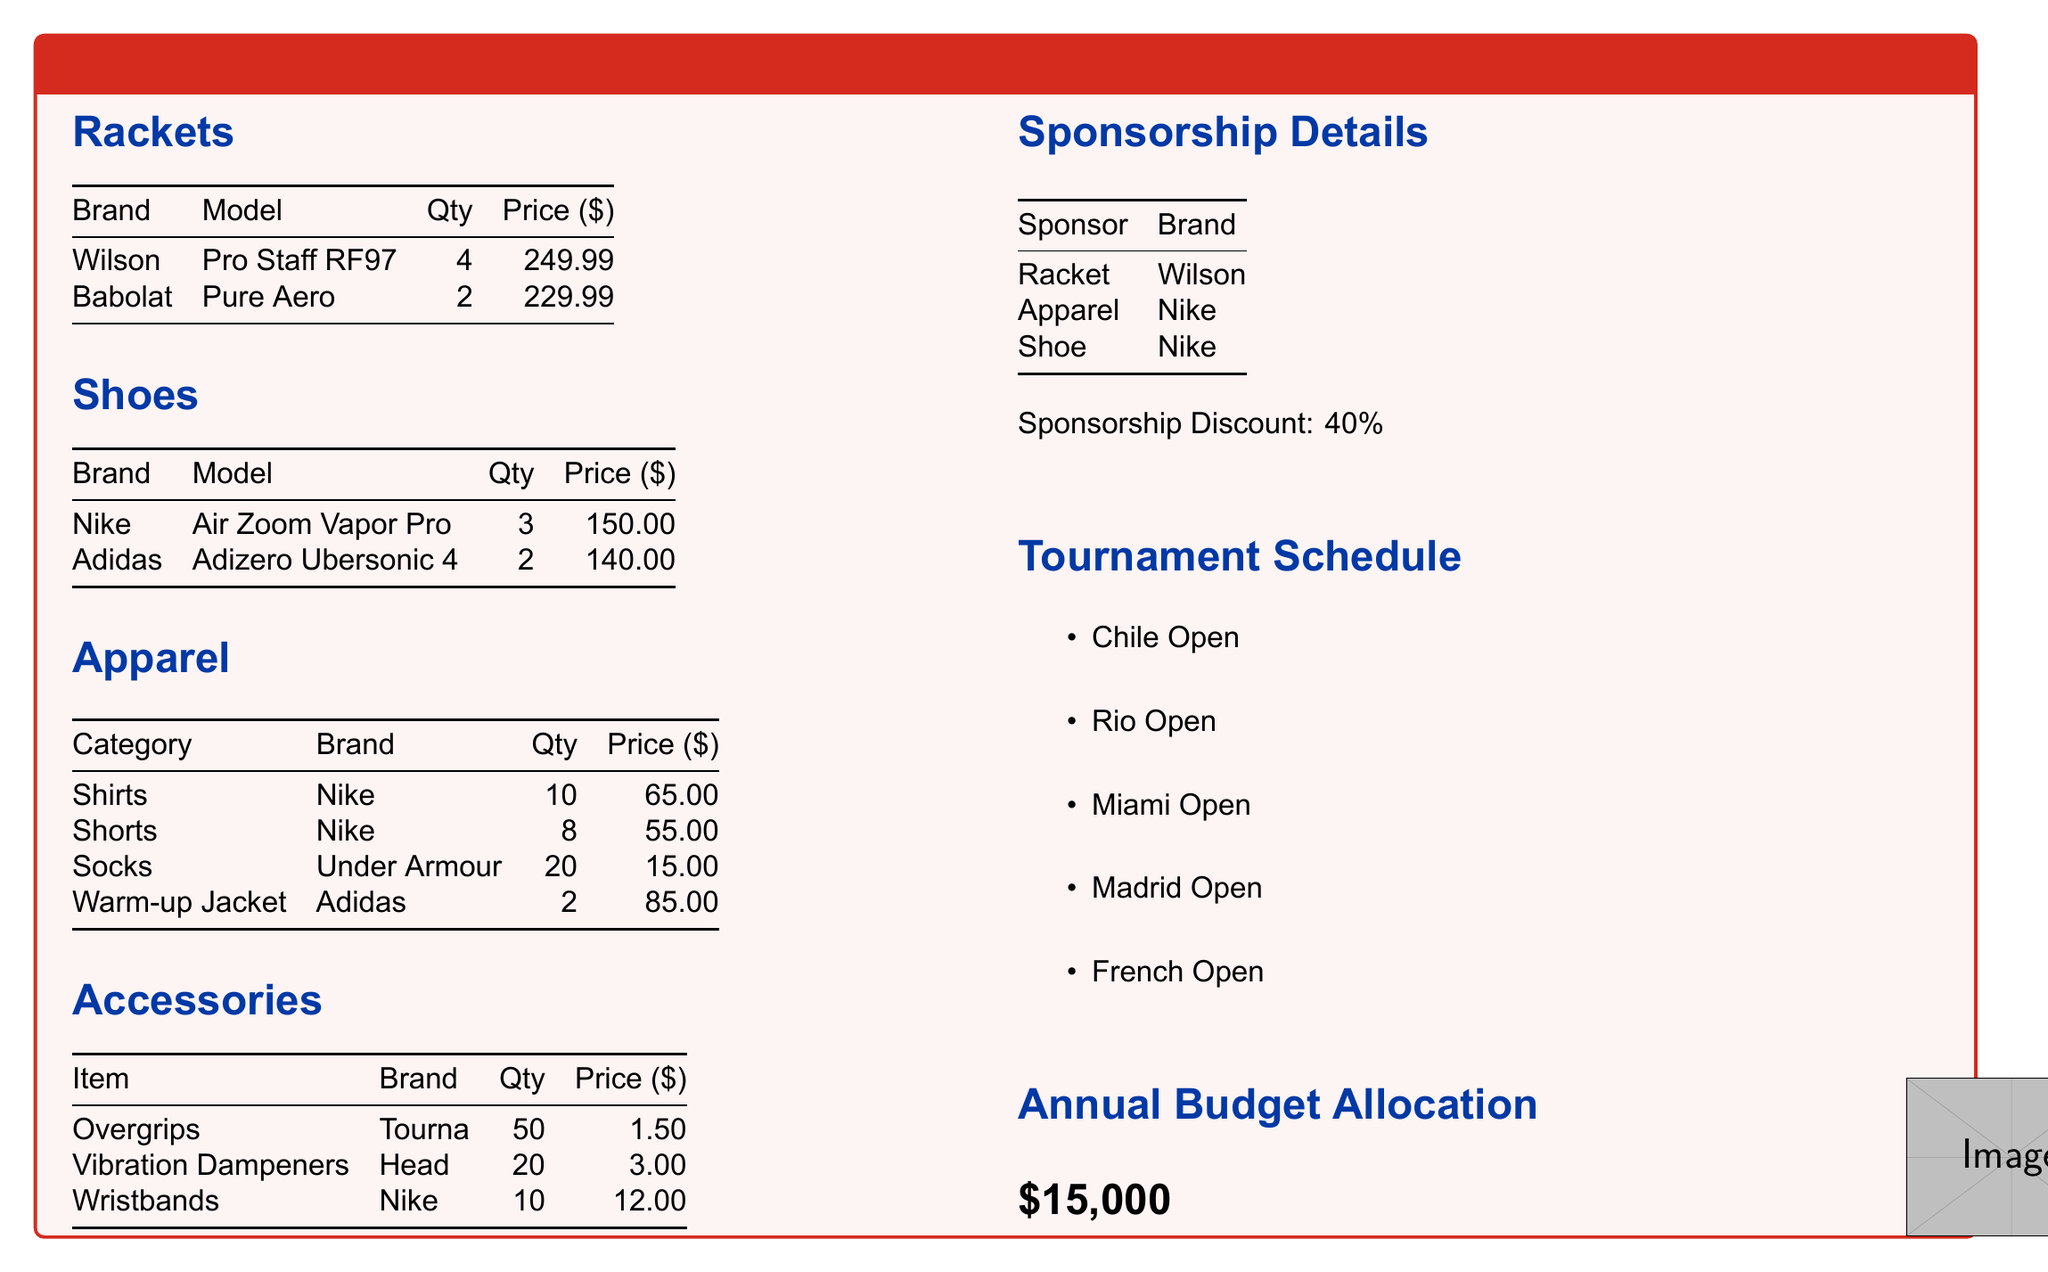What is the total cost of rackets? The total cost of rackets is calculated by multiplying the quantity by the price for each model: (4 x 249.99) + (2 x 229.99) = 999.96 + 459.98 = 1459.94.
Answer: 1459.94 How many pairs of shoes are allocated? The total quantity of shoes allocated is provided in the document as the sum of all shoes: 3 + 2 = 5.
Answer: 5 What is the brand of the warm-up jacket? The document specifies that the brand of the warm-up jacket is Adidas.
Answer: Adidas What is the total quantity of overgrips purchased? The total quantity of overgrips is listed in the accessories section, where it states 50 overgrips.
Answer: 50 What percentage discount do sponsorships provide? The document notes that sponsorship provides a discount of 40%.
Answer: 40% Which brand is associated with apparel sponsorship? The apparel sponsorship details in the document list Nike as the brand.
Answer: Nike How many models of Babolat rackets are included? Only one model of Babolat rackets is mentioned in the document, which is the Pure Aero.
Answer: 1 What is the total budget allocated for equipment? The annual budget allocation specified in the document is $15,000.
Answer: $15,000 Which two brands are listed for shoes? Both Nike and Adidas are mentioned in the shoes section of the document.
Answer: Nike and Adidas 